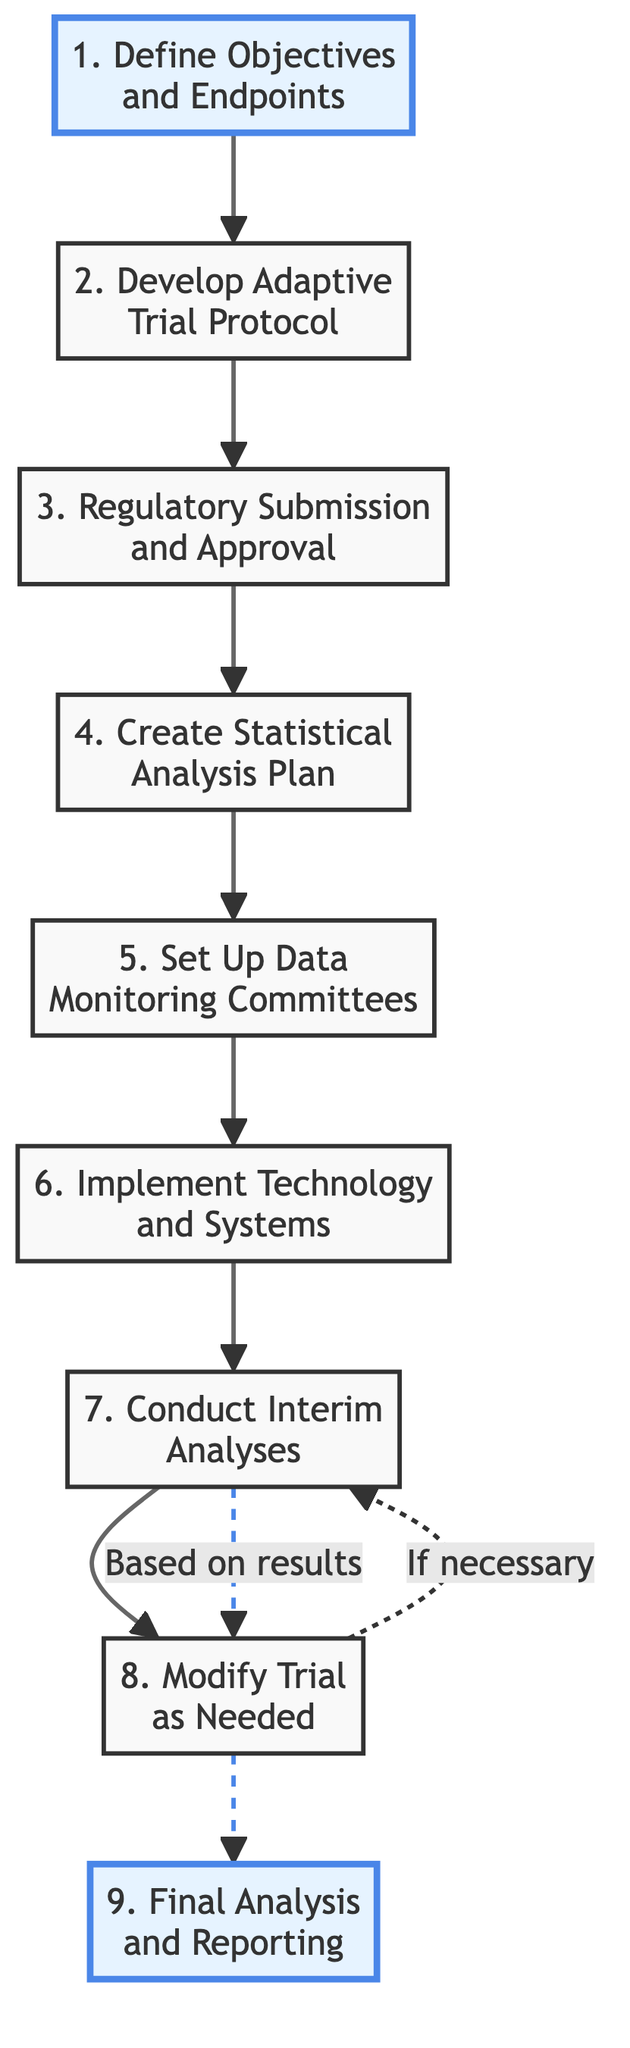What is the first step in the adaptive clinical trial design? The first step is "Define Objectives and Endpoints." This can be found as the first node in the diagram, labeled as step 1.
Answer: Define Objectives and Endpoints How many total steps are there in the diagram? By counting the nodes listed in the diagram, there are nine distinct steps included in the flow of the adaptive clinical trial design.
Answer: 9 Which step follows "Regulatory Submission and Approval"? The next step after "Regulatory Submission and Approval," which is step 3, is "Create Statistical Analysis Plan," represented as step 4 in the diagram.
Answer: Create Statistical Analysis Plan What happens after conducting interim analyses? After conducting interim analyses, which is step 7, the next possible action is to "Modify Trial as Needed," shown as step 8 in the diagram.
Answer: Modify Trial as Needed Is there a feedback mechanism between interim analyses and trial modifications? Yes, there is a feedback mechanism indicated by the dashed arrow connecting steps 7 and 8, showing that interim analyses may lead back to the need for further analyses if necessary.
Answer: Yes 